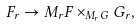Convert formula to latex. <formula><loc_0><loc_0><loc_500><loc_500>F _ { r } \to M _ { r } F \times _ { M _ { r } G } G _ { r } ,</formula> 